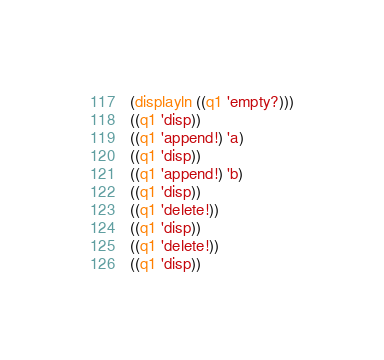<code> <loc_0><loc_0><loc_500><loc_500><_Scheme_>(displayln ((q1 'empty?)))
((q1 'disp))
((q1 'append!) 'a)
((q1 'disp))
((q1 'append!) 'b)
((q1 'disp))
((q1 'delete!))
((q1 'disp))
((q1 'delete!))
((q1 'disp))
</code> 